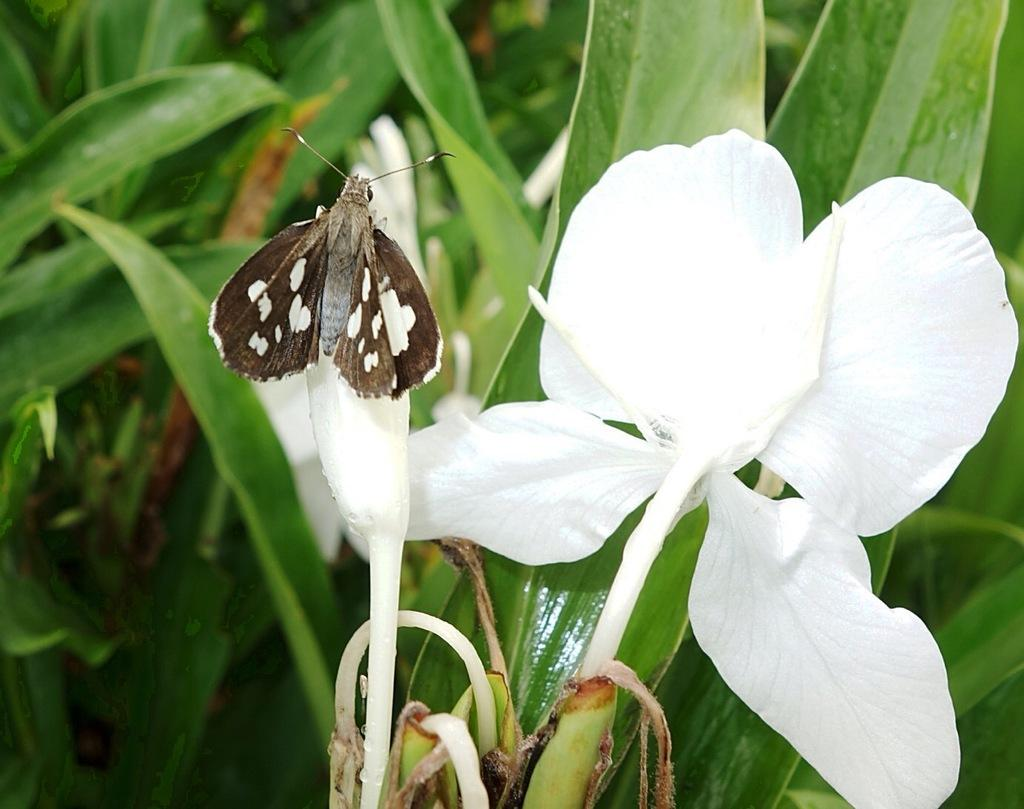What is on the bud in the image? There is an insect on a bud in the image. What type of plant is featured in the image? There is a flower in the image. What else can be seen in the image besides the flower? There are plants in the image. What type of brush is used to apply oil to the flower in the image? There is no brush or oil present in the image; it features an insect on a bud and a flower. 